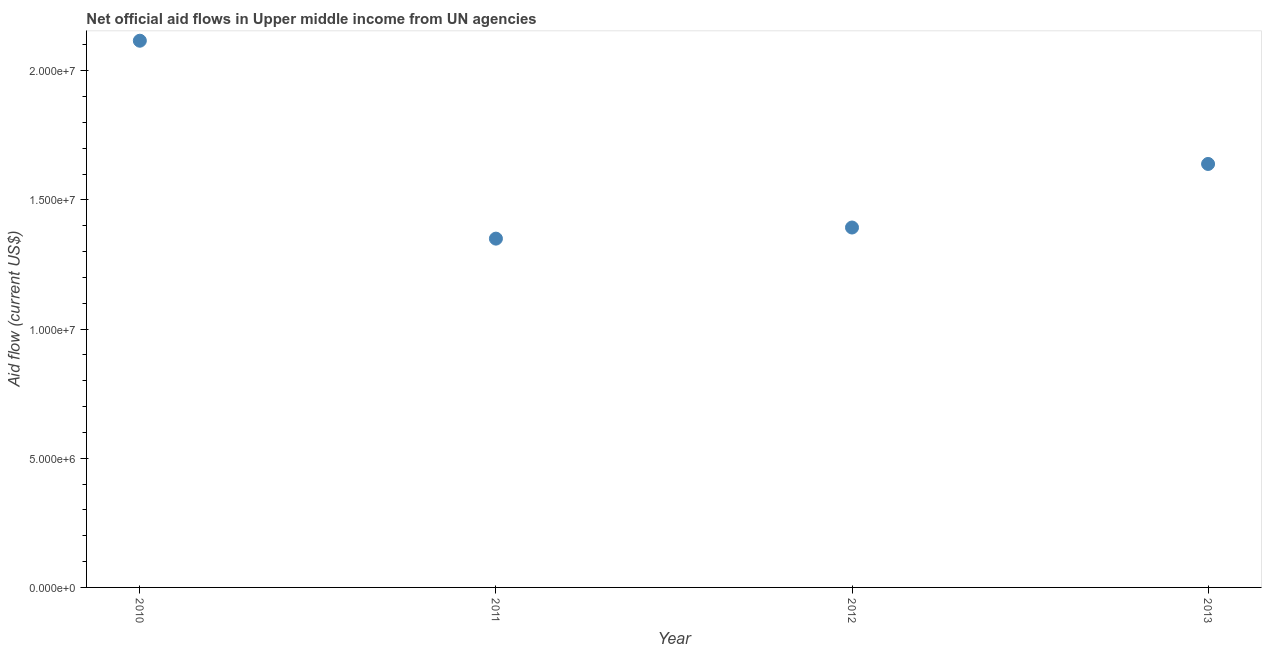What is the net official flows from un agencies in 2013?
Provide a succinct answer. 1.64e+07. Across all years, what is the maximum net official flows from un agencies?
Ensure brevity in your answer.  2.12e+07. Across all years, what is the minimum net official flows from un agencies?
Your answer should be compact. 1.35e+07. In which year was the net official flows from un agencies maximum?
Make the answer very short. 2010. What is the sum of the net official flows from un agencies?
Your response must be concise. 6.50e+07. What is the difference between the net official flows from un agencies in 2010 and 2012?
Provide a short and direct response. 7.23e+06. What is the average net official flows from un agencies per year?
Your answer should be compact. 1.62e+07. What is the median net official flows from un agencies?
Offer a very short reply. 1.52e+07. What is the ratio of the net official flows from un agencies in 2011 to that in 2013?
Make the answer very short. 0.82. Is the net official flows from un agencies in 2012 less than that in 2013?
Your answer should be compact. Yes. What is the difference between the highest and the second highest net official flows from un agencies?
Keep it short and to the point. 4.77e+06. What is the difference between the highest and the lowest net official flows from un agencies?
Your answer should be compact. 7.66e+06. Does the net official flows from un agencies monotonically increase over the years?
Provide a succinct answer. No. How many dotlines are there?
Give a very brief answer. 1. What is the difference between two consecutive major ticks on the Y-axis?
Your answer should be very brief. 5.00e+06. Does the graph contain any zero values?
Your answer should be compact. No. What is the title of the graph?
Provide a short and direct response. Net official aid flows in Upper middle income from UN agencies. What is the Aid flow (current US$) in 2010?
Provide a short and direct response. 2.12e+07. What is the Aid flow (current US$) in 2011?
Your answer should be compact. 1.35e+07. What is the Aid flow (current US$) in 2012?
Give a very brief answer. 1.39e+07. What is the Aid flow (current US$) in 2013?
Offer a very short reply. 1.64e+07. What is the difference between the Aid flow (current US$) in 2010 and 2011?
Your response must be concise. 7.66e+06. What is the difference between the Aid flow (current US$) in 2010 and 2012?
Give a very brief answer. 7.23e+06. What is the difference between the Aid flow (current US$) in 2010 and 2013?
Give a very brief answer. 4.77e+06. What is the difference between the Aid flow (current US$) in 2011 and 2012?
Offer a very short reply. -4.30e+05. What is the difference between the Aid flow (current US$) in 2011 and 2013?
Provide a short and direct response. -2.89e+06. What is the difference between the Aid flow (current US$) in 2012 and 2013?
Ensure brevity in your answer.  -2.46e+06. What is the ratio of the Aid flow (current US$) in 2010 to that in 2011?
Keep it short and to the point. 1.57. What is the ratio of the Aid flow (current US$) in 2010 to that in 2012?
Your answer should be compact. 1.52. What is the ratio of the Aid flow (current US$) in 2010 to that in 2013?
Provide a succinct answer. 1.29. What is the ratio of the Aid flow (current US$) in 2011 to that in 2013?
Make the answer very short. 0.82. 